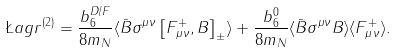<formula> <loc_0><loc_0><loc_500><loc_500>\L a g r ^ { ( 2 ) } = \frac { b _ { 6 } ^ { D / F } } { 8 m _ { N } } \langle \bar { B } \sigma ^ { \mu \nu } \left [ F _ { \mu \nu } ^ { + } , B \right ] _ { \pm } \rangle + \frac { b _ { 6 } ^ { 0 } } { 8 m _ { N } } \langle \bar { B } \sigma ^ { \mu \nu } B \rangle \langle F _ { \mu \nu } ^ { + } \rangle .</formula> 